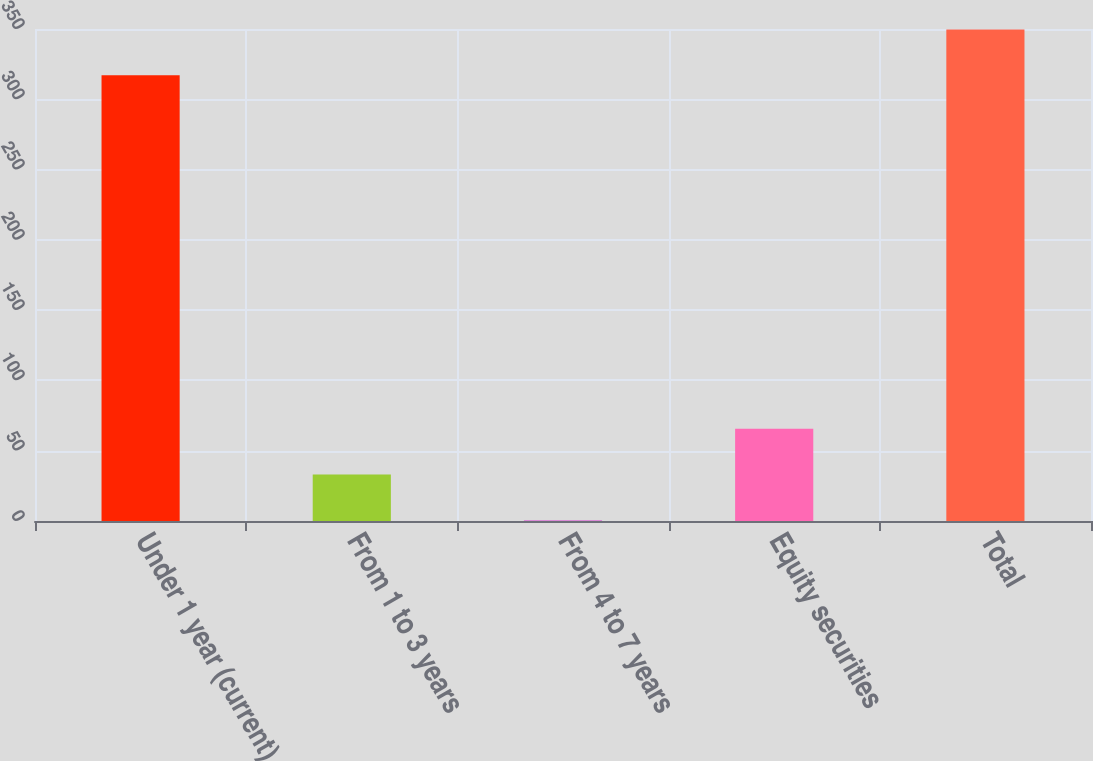Convert chart. <chart><loc_0><loc_0><loc_500><loc_500><bar_chart><fcel>Under 1 year (current)<fcel>From 1 to 3 years<fcel>From 4 to 7 years<fcel>Equity securities<fcel>Total<nl><fcel>317.1<fcel>33.14<fcel>0.6<fcel>65.68<fcel>349.64<nl></chart> 